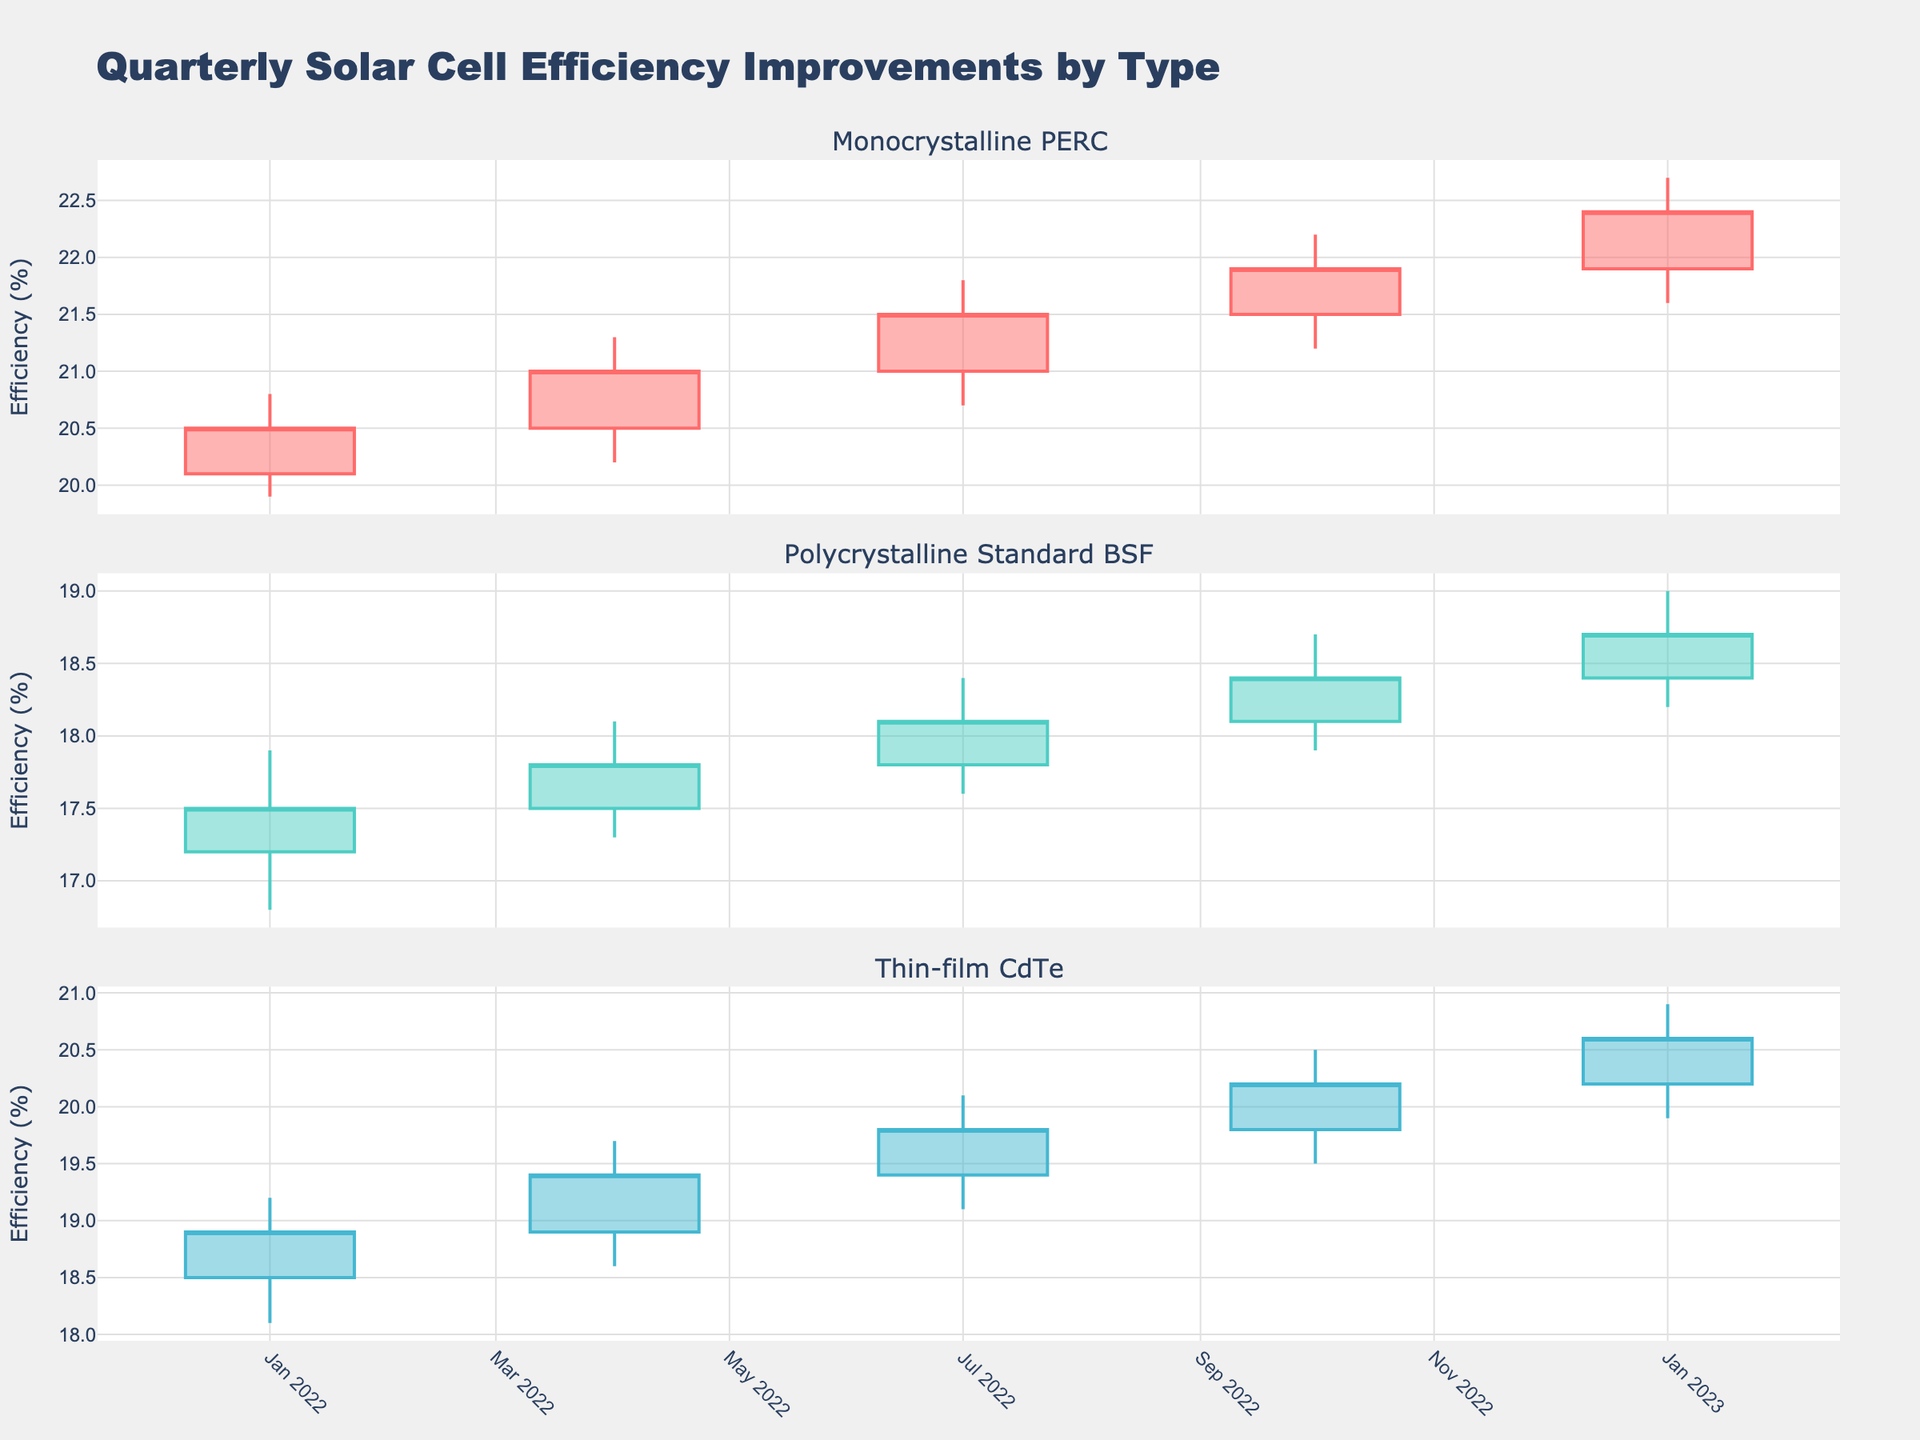What's the title of the figure? The title is located at the top of the visualization and it states the overall subject of the plots.
Answer: Quarterly Solar Cell Efficiency Improvements by Type What does the y-axis measure? The y-axis on each subplot measures solar cell efficiency, denoted as efficiency (%).
Answer: Efficiency (%) How many subplots are present in the figure? The figure consists of three subplots, each representing a different type of solar cell.
Answer: 3 Which solar cell type had the highest maximum efficiency in 2023-Q1? The third subplot for Thin-film CdTe shows the highest maximum efficiency with a "High" point of 20.9 in 2023-Q1.
Answer: Thin-film CdTe How did Monocrystalline PERC efficiency change from 2022-Q4 to 2023-Q1? Comparing the "Close" value from 2022-Q4 (21.9) to the "Close" value of 2023-Q1 (22.4) in the first subplot, Monocrystalline PERC efficiency increased.
Answer: Increased Which manufacturing process had the smallest efficiency increase from 2022-Q4 to 2023-Q1? Comparing the "Close" values in each subplot, Polycrystalline Standard BSF had the smallest increase (18.4 to 18.7, a difference of 0.3).
Answer: Polycrystalline Standard BSF What were the open and close efficiencies for Polycrystalline Standard BSF in 2022-Q3? In the second subplot, Polycrystalline Standard BSF had an "Open" value of 17.8 and a "Close" value of 18.1 in 2022-Q3.
Answer: Open: 17.8, Close: 18.1 For which month and cell type was there a decreasing trend in efficiency? In the first subplot for Monocrystalline PERC in 2022-Q1, the "Open" value (20.1) is higher compared to the "Close" value (20.5).
Answer: 2022-Q1, Monocrystalline PERC What is the range of efficiency values for Thin-film CdTe in 2022-Q4? The third subplot shows Thin-film CdTe has a "Low" value of 19.5 and a "High" value of 20.5 in 2022-Q4. The range is  20.5 - 19.5 = 1.
Answer: 1 Which quarter shows the highest overall efficiency improvement across all cell types? By observing the "High" values across all subplots, 2023-Q1 has the highest "High" values for all solar cell types.
Answer: 2023-Q1 